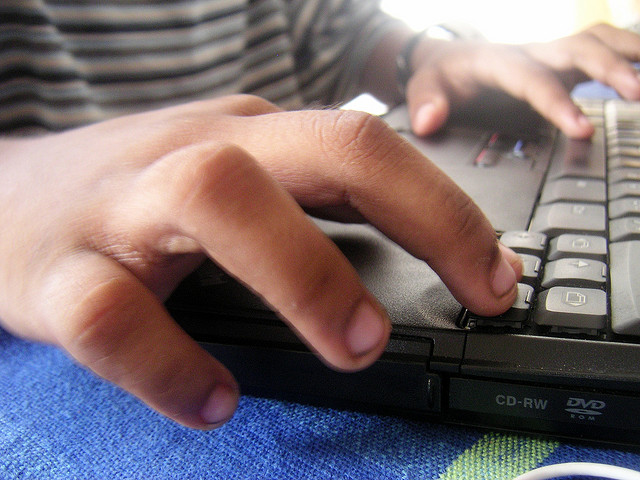Read all the text in this image. CD RW DVD ROM 